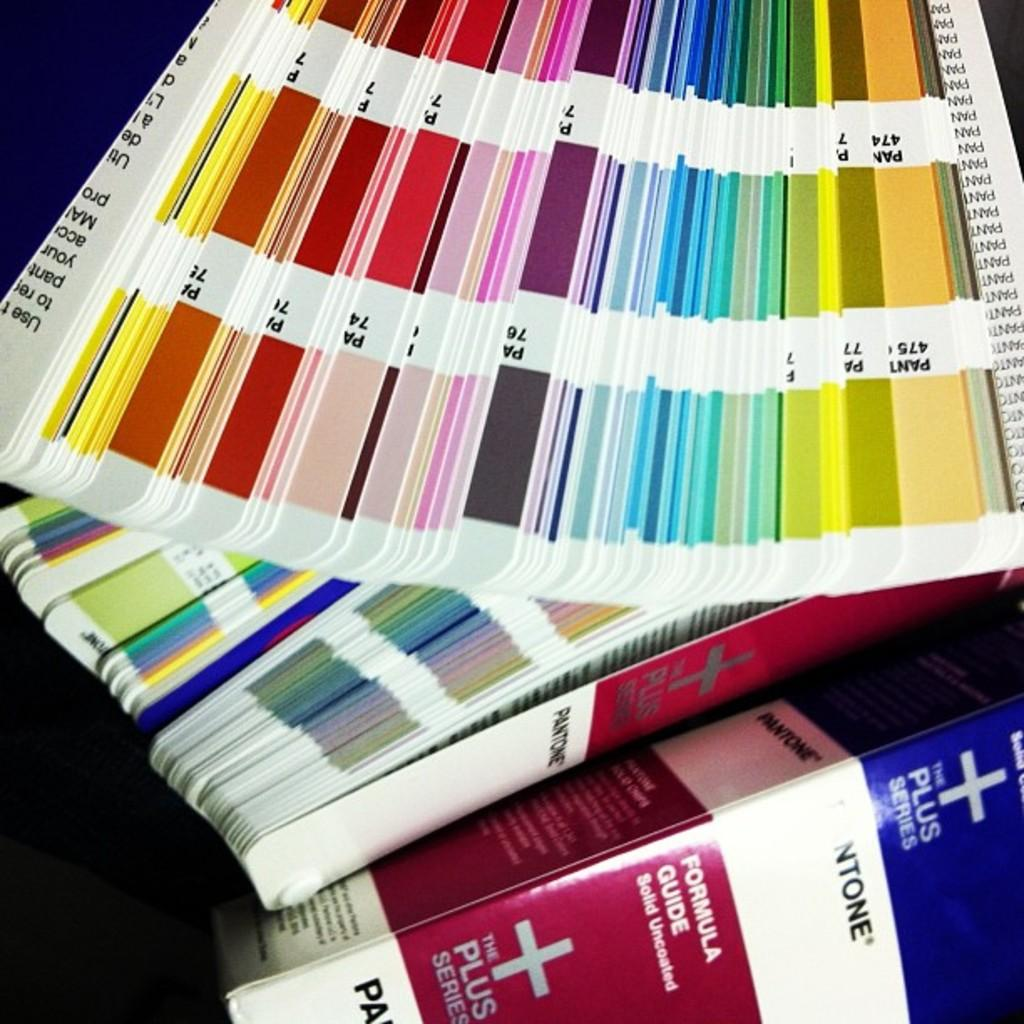<image>
Relay a brief, clear account of the picture shown. Some color swatches have the PANTONE label on the side. 